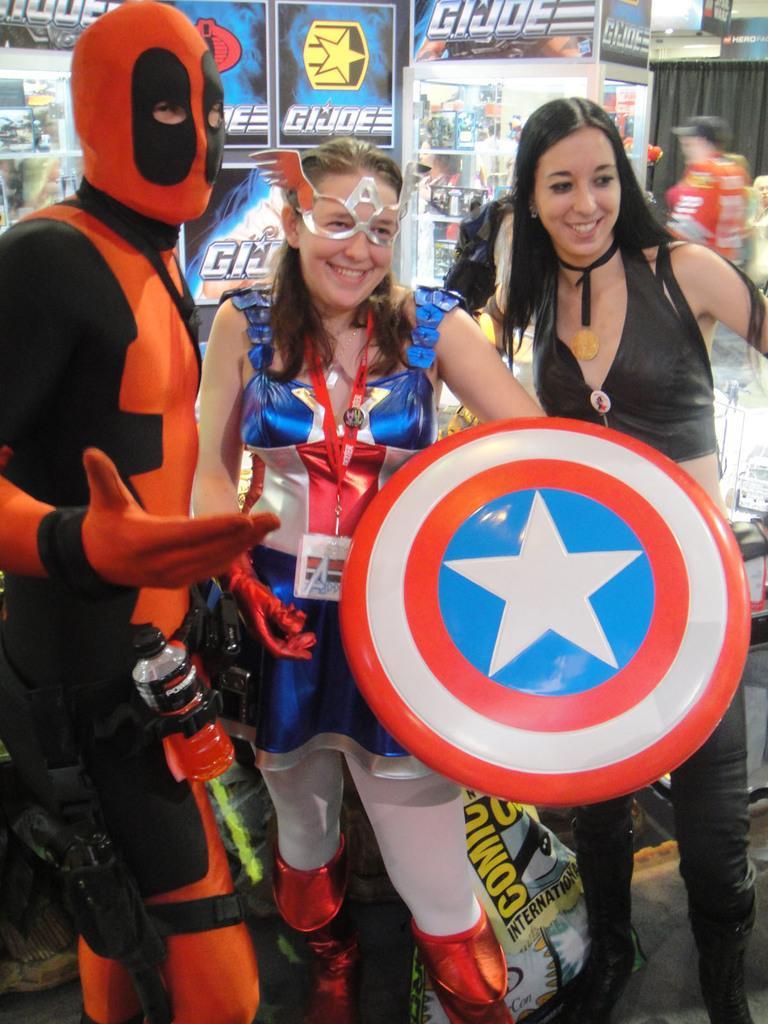Could you give a brief overview of what you see in this image? There are three people standing and smiling. Among them two of them wore fancy dresses. This woman is holding a marvel captain america shield in her hand. I think these are the toys. In the background, I can see a person standing. This is the cloth hanging to the hanger. 